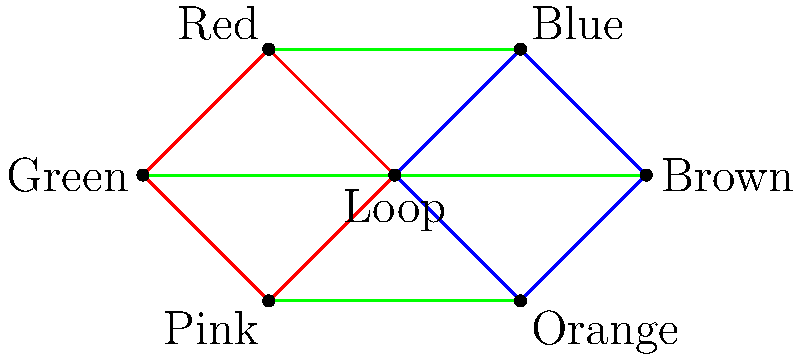As a cabdriver in Chicago, you're familiar with the city's public transportation network. The graph above represents a simplified version of Chicago's 'L' train system, where each vertex represents a station and each edge represents a direct connection between stations. The Loop is the central hub where all lines converge. How many different colors of train lines are represented in this graph? To answer this question, we need to analyze the graph and count the distinct colors of edges:

1. Blue line: Represented by the blue edges connecting the Loop, Blue, Brown, and Orange stations.
2. Red line: Represented by the red edges connecting the Loop, Red, Green, and Pink stations.
3. Green line: Represented by the green edges connecting Blue and Red, Brown and Green, and Orange and Pink stations.

Additionally, we can see labels for other colors that don't have their own edges:

4. Brown line: Labeled at one of the vertices.
5. Orange line: Labeled at one of the vertices.
6. Pink line: Labeled at one of the vertices.

In total, we can count 6 different colors of train lines represented in this graph.
Answer: 6 colors 